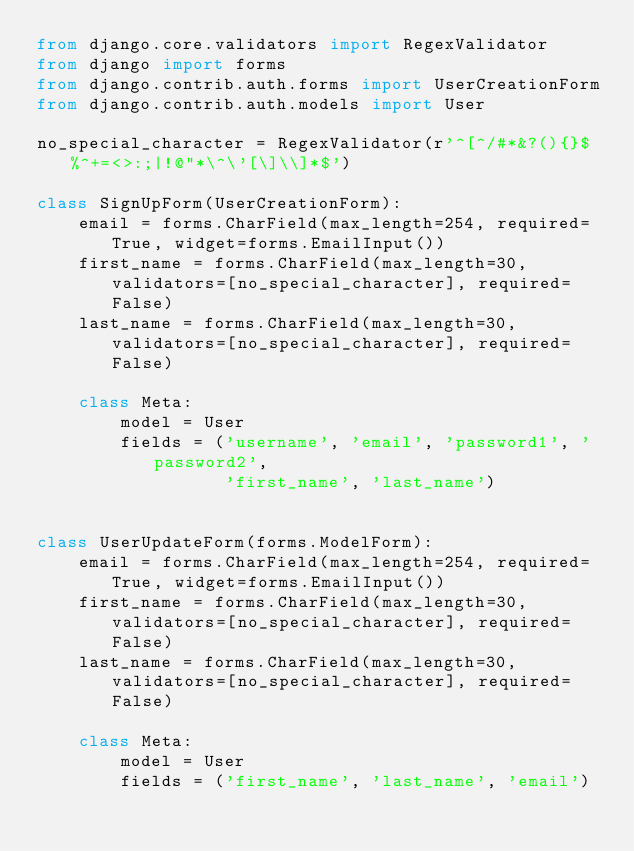<code> <loc_0><loc_0><loc_500><loc_500><_Python_>from django.core.validators import RegexValidator
from django import forms
from django.contrib.auth.forms import UserCreationForm
from django.contrib.auth.models import User

no_special_character = RegexValidator(r'^[^/#*&?(){}$%^+=<>:;|!@"*\^\'[\]\\]*$')

class SignUpForm(UserCreationForm):
    email = forms.CharField(max_length=254, required=True, widget=forms.EmailInput())
    first_name = forms.CharField(max_length=30, validators=[no_special_character], required=False)
    last_name = forms.CharField(max_length=30, validators=[no_special_character], required=False)

    class Meta:
        model = User
        fields = ('username', 'email', 'password1', 'password2',
                  'first_name', 'last_name')


class UserUpdateForm(forms.ModelForm):
    email = forms.CharField(max_length=254, required=True, widget=forms.EmailInput())
    first_name = forms.CharField(max_length=30, validators=[no_special_character], required=False)
    last_name = forms.CharField(max_length=30, validators=[no_special_character], required=False)

    class Meta:
        model = User
        fields = ('first_name', 'last_name', 'email')
</code> 